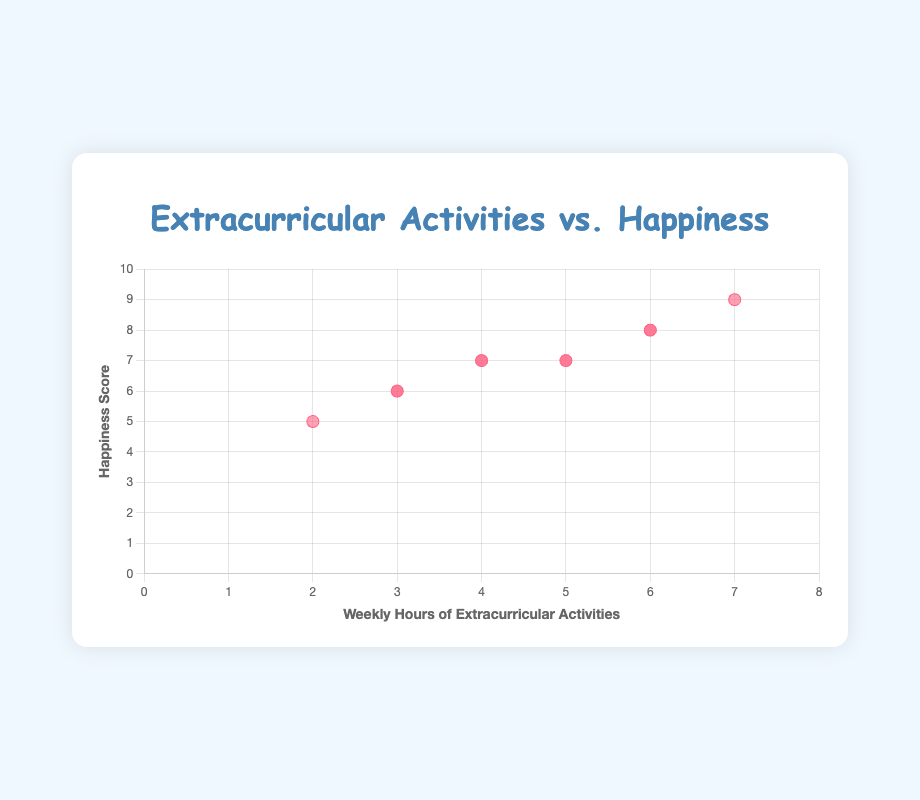Which child spends the most time on extracurricular activities? By looking at the x-axis, Noah has the highest value of weekly hours at 7.
Answer: Noah How many hours does Emma spend on her extracurricular activity, and what is her happiness score? Emma's data point corresponds to 2 hours on the x-axis and 5 on the y-axis.
Answer: 2 hours, 5 Who has the lowest happiness score, and how many hours do they spend on their activity? Emma has the lowest happiness score, which is 5, and she spends 2 hours on her activity.
Answer: Emma, 2 hours What's the average happiness score of children who spend exactly 6 hours per week on extracurricular activities? Only William and Mason spend 6 hours per week. Their happiness scores are 8 and 8 respectively. The average is (8 + 8) / 2 = 8.
Answer: 8 Is there a child who spends the same number of hours on extracurricular activities but has different happiness scores compared to another child? Yes, Sophia and Ava both spend 5 hours, but their happiness scores differ: Sophia has 7, and Ava also has 7.
Answer: Yes Who spends 3 hours on extracurricular activities, and what are their happiness scores? Olivia and Isabella both spend 3 hours on their activities. Their happiness scores are 6 and 6 respectively.
Answer: Olivia, 6 and Isabella, 6 Compare the weekly hours of Olivia and Sophia. Who spends more time, and by how much? Sophia spends 5 hours while Olivia spends 3. Therefore, Sophia spends 5 - 3 = 2 more hours than Olivia.
Answer: Sophia, 2 hours What's the total weekly hours spent by children who have a happiness score of 7? Sophia, Liam, Ava, and James each have a happiness score of 7, and their hours are 5, 4, 5, and 4 respectively. The total is 5 + 4 + 5 + 4 = 18 hours.
Answer: 18 hours What is the happiness score distribution for children who spend at least 5 hours on extracurricular activities? Children who spend at least 5 hours are William (6, 8), Sophia (5, 7), Noah (7, 9), Mason (6, 8), and Ava (5, 7). Happiness scores are 8, 7, 9, 8, and 7.
Answer: 8, 7, 9, 8, 7 